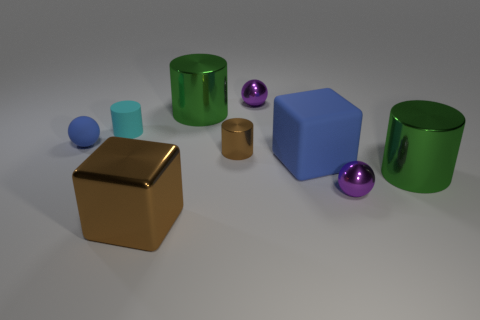Subtract all small brown cylinders. How many cylinders are left? 3 Add 1 large cyan matte spheres. How many objects exist? 10 Subtract all cubes. How many objects are left? 7 Subtract all brown blocks. How many blocks are left? 1 Subtract 2 cylinders. How many cylinders are left? 2 Subtract all green cylinders. Subtract all gray balls. How many cylinders are left? 2 Subtract all purple cubes. How many purple balls are left? 2 Subtract all small things. Subtract all big cubes. How many objects are left? 2 Add 5 small blue matte objects. How many small blue matte objects are left? 6 Add 5 tiny rubber things. How many tiny rubber things exist? 7 